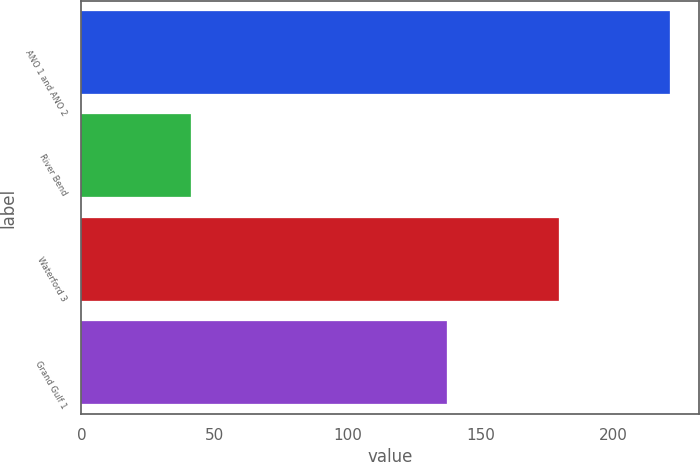<chart> <loc_0><loc_0><loc_500><loc_500><bar_chart><fcel>ANO 1 and ANO 2<fcel>River Bend<fcel>Waterford 3<fcel>Grand Gulf 1<nl><fcel>221<fcel>41.2<fcel>179.4<fcel>137.2<nl></chart> 